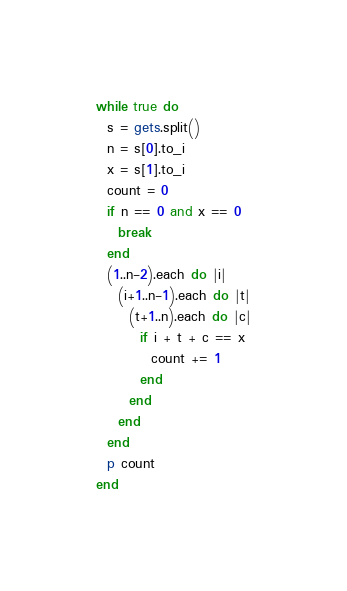Convert code to text. <code><loc_0><loc_0><loc_500><loc_500><_Ruby_>while true do
  s = gets.split()
  n = s[0].to_i
  x = s[1].to_i
  count = 0
  if n == 0 and x == 0
    break
  end
  (1..n-2).each do |i|
    (i+1..n-1).each do |t|
      (t+1..n).each do |c|
        if i + t + c == x
          count += 1
        end
      end
    end
  end
  p count
end</code> 